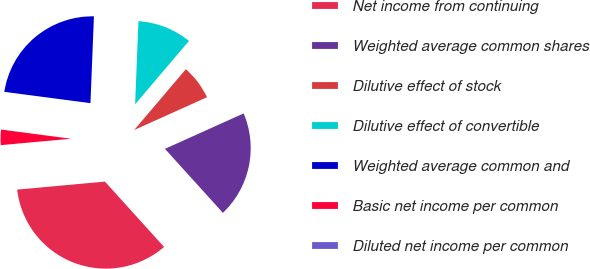Convert chart. <chart><loc_0><loc_0><loc_500><loc_500><pie_chart><fcel>Net income from continuing<fcel>Weighted average common shares<fcel>Dilutive effect of stock<fcel>Dilutive effect of convertible<fcel>Weighted average common and<fcel>Basic net income per common<fcel>Diluted net income per common<nl><fcel>35.26%<fcel>20.03%<fcel>7.05%<fcel>10.58%<fcel>23.56%<fcel>3.53%<fcel>0.0%<nl></chart> 